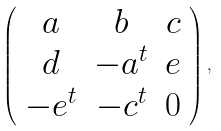<formula> <loc_0><loc_0><loc_500><loc_500>\left ( \begin{array} { c c c } a & b & c \\ d & - a ^ { t } & e \\ - e ^ { t } & - c ^ { t } & 0 \end{array} \right ) ,</formula> 